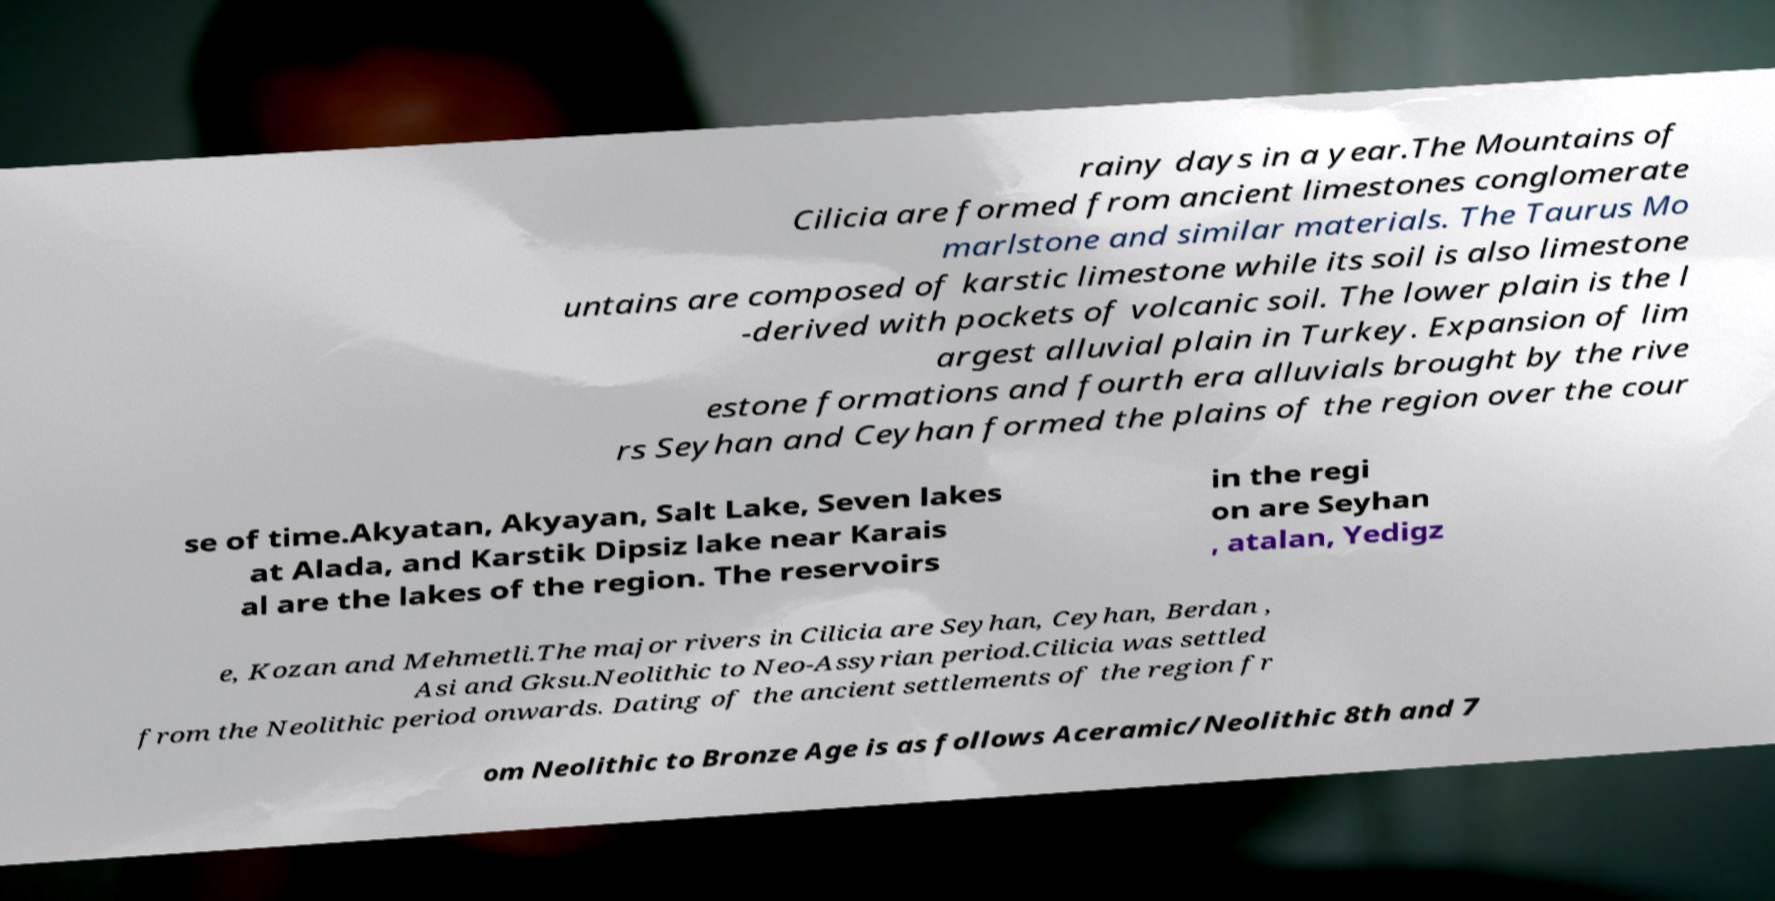Can you accurately transcribe the text from the provided image for me? rainy days in a year.The Mountains of Cilicia are formed from ancient limestones conglomerate marlstone and similar materials. The Taurus Mo untains are composed of karstic limestone while its soil is also limestone -derived with pockets of volcanic soil. The lower plain is the l argest alluvial plain in Turkey. Expansion of lim estone formations and fourth era alluvials brought by the rive rs Seyhan and Ceyhan formed the plains of the region over the cour se of time.Akyatan, Akyayan, Salt Lake, Seven lakes at Alada, and Karstik Dipsiz lake near Karais al are the lakes of the region. The reservoirs in the regi on are Seyhan , atalan, Yedigz e, Kozan and Mehmetli.The major rivers in Cilicia are Seyhan, Ceyhan, Berdan , Asi and Gksu.Neolithic to Neo-Assyrian period.Cilicia was settled from the Neolithic period onwards. Dating of the ancient settlements of the region fr om Neolithic to Bronze Age is as follows Aceramic/Neolithic 8th and 7 